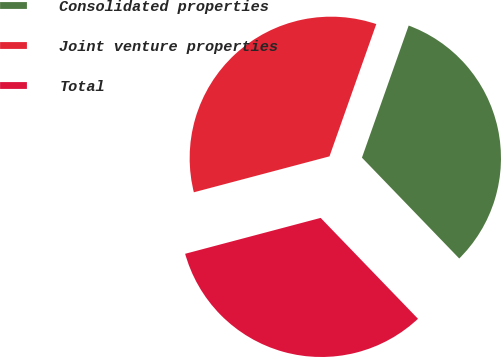Convert chart. <chart><loc_0><loc_0><loc_500><loc_500><pie_chart><fcel>Consolidated properties<fcel>Joint venture properties<fcel>Total<nl><fcel>32.37%<fcel>34.53%<fcel>33.09%<nl></chart> 